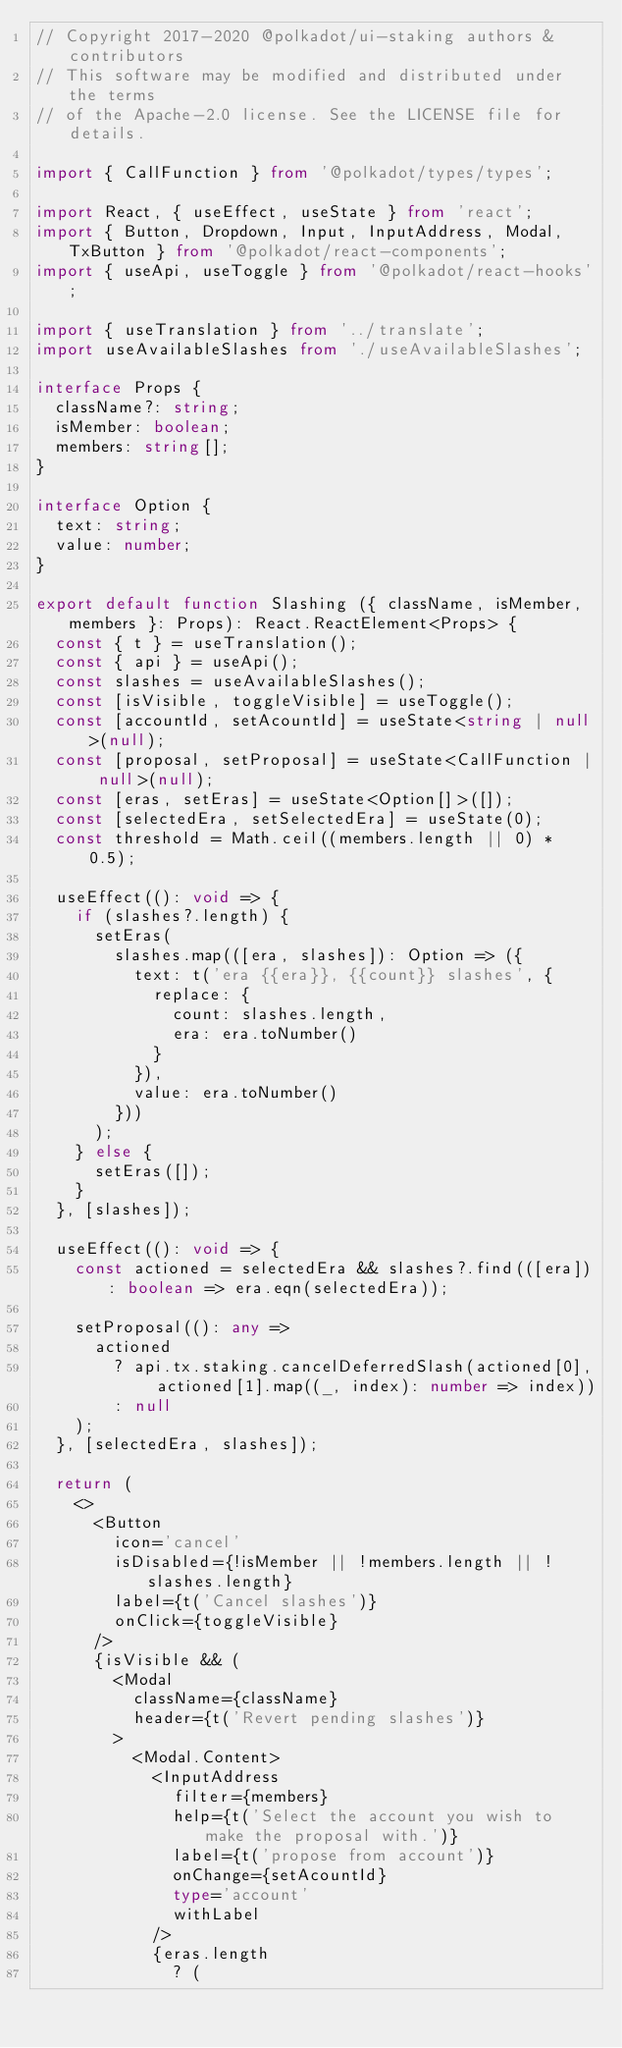Convert code to text. <code><loc_0><loc_0><loc_500><loc_500><_TypeScript_>// Copyright 2017-2020 @polkadot/ui-staking authors & contributors
// This software may be modified and distributed under the terms
// of the Apache-2.0 license. See the LICENSE file for details.

import { CallFunction } from '@polkadot/types/types';

import React, { useEffect, useState } from 'react';
import { Button, Dropdown, Input, InputAddress, Modal, TxButton } from '@polkadot/react-components';
import { useApi, useToggle } from '@polkadot/react-hooks';

import { useTranslation } from '../translate';
import useAvailableSlashes from './useAvailableSlashes';

interface Props {
  className?: string;
  isMember: boolean;
  members: string[];
}

interface Option {
  text: string;
  value: number;
}

export default function Slashing ({ className, isMember, members }: Props): React.ReactElement<Props> {
  const { t } = useTranslation();
  const { api } = useApi();
  const slashes = useAvailableSlashes();
  const [isVisible, toggleVisible] = useToggle();
  const [accountId, setAcountId] = useState<string | null>(null);
  const [proposal, setProposal] = useState<CallFunction | null>(null);
  const [eras, setEras] = useState<Option[]>([]);
  const [selectedEra, setSelectedEra] = useState(0);
  const threshold = Math.ceil((members.length || 0) * 0.5);

  useEffect((): void => {
    if (slashes?.length) {
      setEras(
        slashes.map(([era, slashes]): Option => ({
          text: t('era {{era}}, {{count}} slashes', {
            replace: {
              count: slashes.length,
              era: era.toNumber()
            }
          }),
          value: era.toNumber()
        }))
      );
    } else {
      setEras([]);
    }
  }, [slashes]);

  useEffect((): void => {
    const actioned = selectedEra && slashes?.find(([era]): boolean => era.eqn(selectedEra));

    setProposal((): any =>
      actioned
        ? api.tx.staking.cancelDeferredSlash(actioned[0], actioned[1].map((_, index): number => index))
        : null
    );
  }, [selectedEra, slashes]);

  return (
    <>
      <Button
        icon='cancel'
        isDisabled={!isMember || !members.length || !slashes.length}
        label={t('Cancel slashes')}
        onClick={toggleVisible}
      />
      {isVisible && (
        <Modal
          className={className}
          header={t('Revert pending slashes')}
        >
          <Modal.Content>
            <InputAddress
              filter={members}
              help={t('Select the account you wish to make the proposal with.')}
              label={t('propose from account')}
              onChange={setAcountId}
              type='account'
              withLabel
            />
            {eras.length
              ? (</code> 